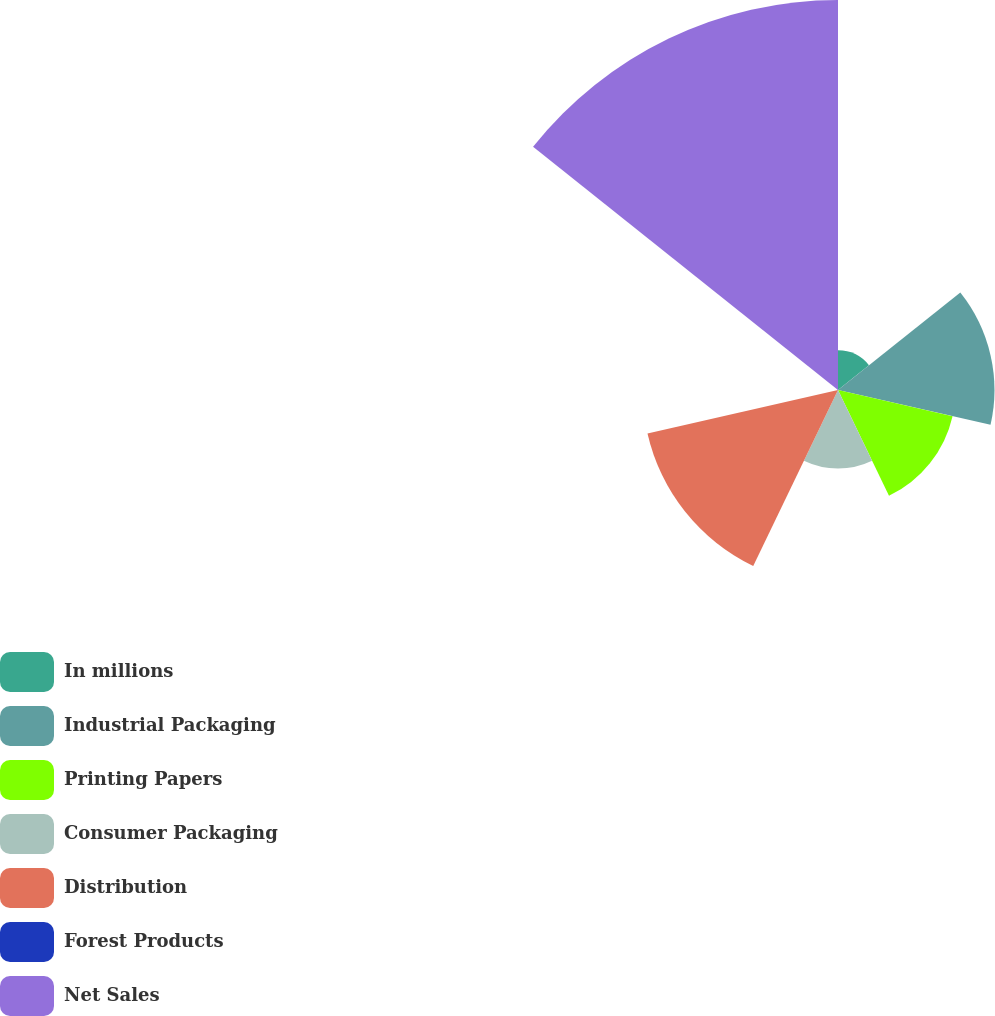Convert chart to OTSL. <chart><loc_0><loc_0><loc_500><loc_500><pie_chart><fcel>In millions<fcel>Industrial Packaging<fcel>Printing Papers<fcel>Consumer Packaging<fcel>Distribution<fcel>Forest Products<fcel>Net Sales<nl><fcel>4.05%<fcel>15.99%<fcel>12.01%<fcel>8.03%<fcel>19.97%<fcel>0.08%<fcel>39.86%<nl></chart> 